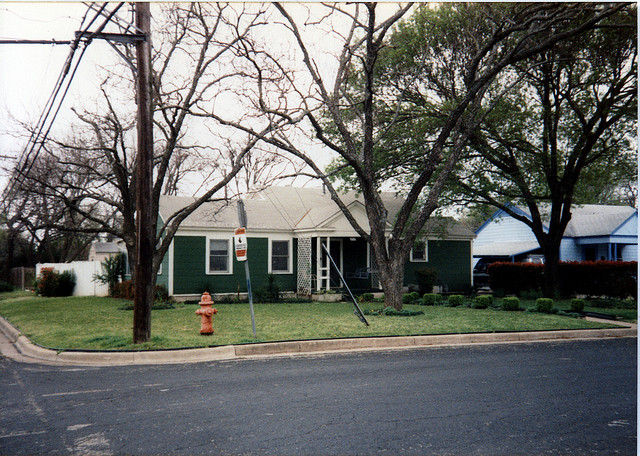What style of architecture is the house in the image? The house appears to be a modest single-story residence, reflecting characteristics of mid-20th century suburban American architecture, often referred to as minimal traditional style. Its simplicity and lack of ornamentation suggest functional design over aesthetic embellishments. 